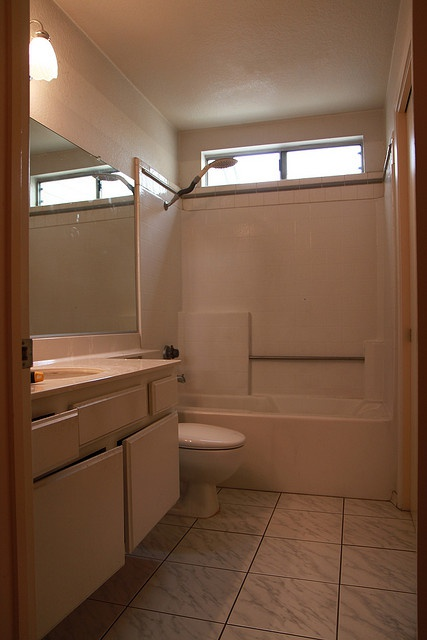Describe the objects in this image and their specific colors. I can see toilet in maroon, gray, and black tones and sink in maroon, salmon, and tan tones in this image. 